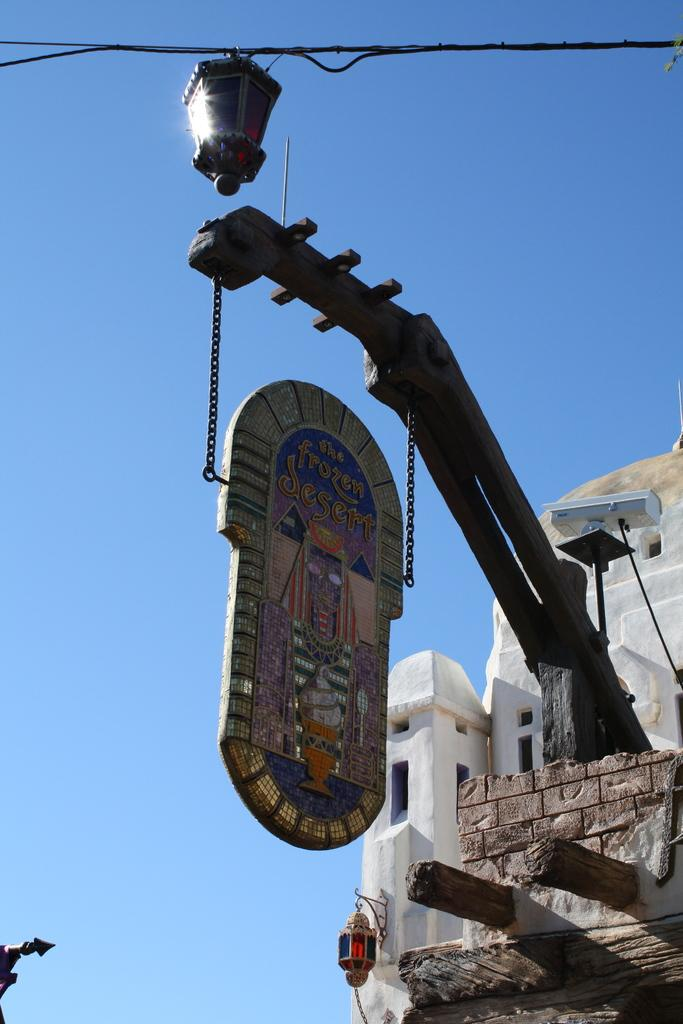What is hanging on a pole in the foreground of the image? There is a board hanging on a pole in the foreground of the image. What is suspended in the top part of the image? There is a lamp on a cable in the top part of the image. What can be seen in the background of the image? There is a building in the background of the image. What is visible in the sky in the background of the image? The sky is visible in the background of the image. Can you see a frog hopping on the board in the image? There is no frog present in the image; it only features a board hanging on a pole, a lamp on a cable, a building in the background, and the sky visible in the background. What message of hope is conveyed by the board in the image? The image does not convey any specific message of hope, as it only shows a board hanging on a pole, a lamp on a cable, a building in the background, and the sky visible in the background. 